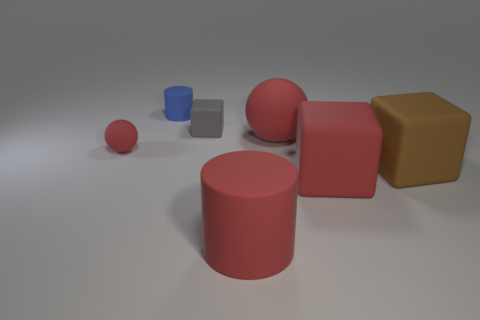Add 2 tiny red things. How many objects exist? 9 Subtract all big blocks. How many blocks are left? 1 Subtract all cylinders. How many objects are left? 5 Subtract all yellow blocks. Subtract all red balls. How many blocks are left? 3 Subtract all red blocks. Subtract all tiny gray matte things. How many objects are left? 5 Add 4 tiny things. How many tiny things are left? 7 Add 1 big red matte objects. How many big red matte objects exist? 4 Subtract 1 blue cylinders. How many objects are left? 6 